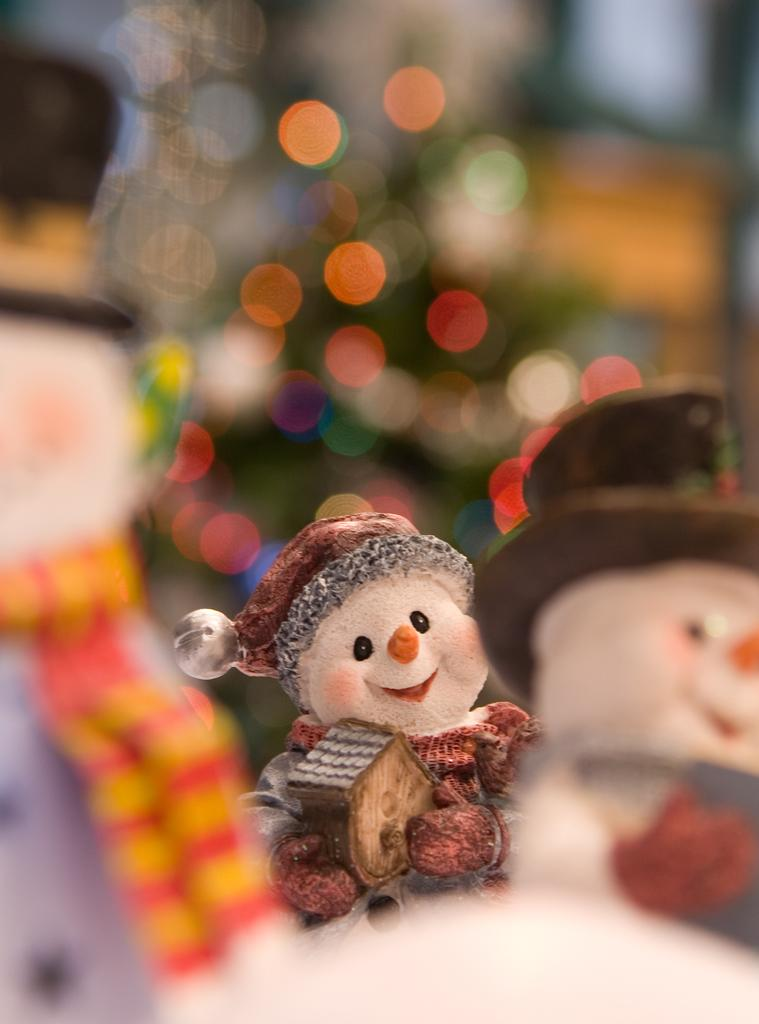What objects can be seen in the image? There are toys in the image. Can you describe the background of the image? The background of the image is blurred. What type of tax is being discussed in the image? There is no discussion of tax in the image, as it only features toys and a blurred background. 